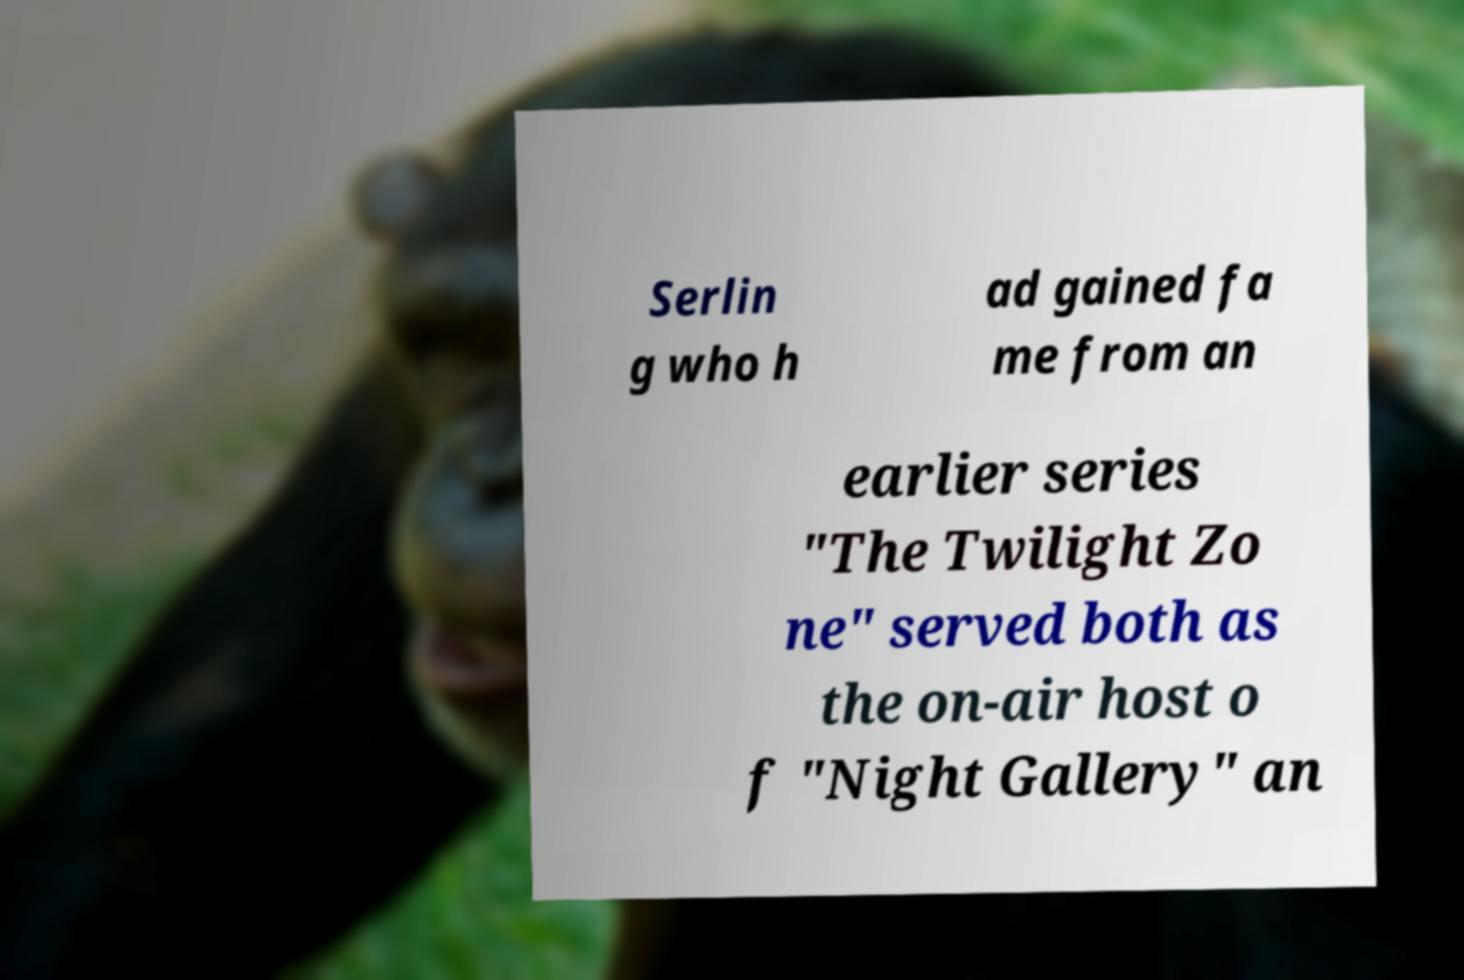Could you assist in decoding the text presented in this image and type it out clearly? Serlin g who h ad gained fa me from an earlier series "The Twilight Zo ne" served both as the on-air host o f "Night Gallery" an 